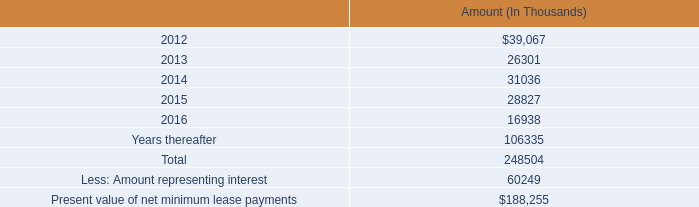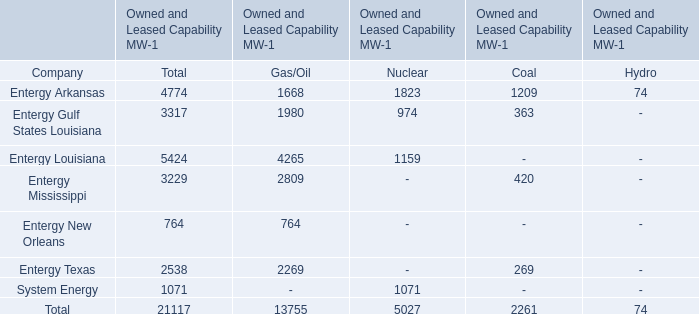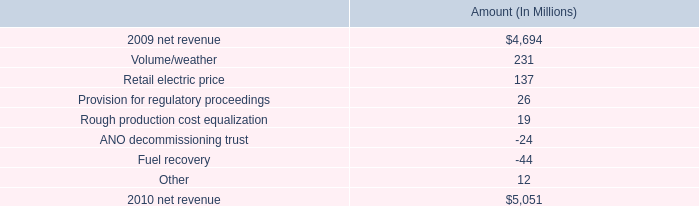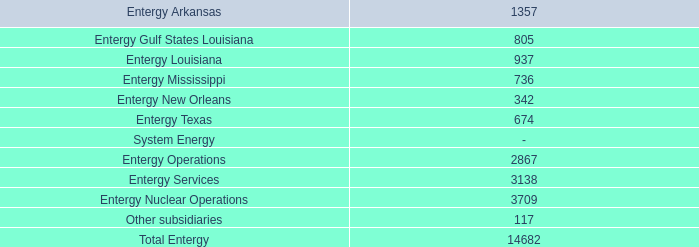What is the Total Owned and Leased Capability MW for Entergy Arkansas? 
Computations: (((1668 + 1823) + 1209) + 74)
Answer: 4774.0. 